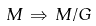Convert formula to latex. <formula><loc_0><loc_0><loc_500><loc_500>M \, \Rightarrow \, M / G</formula> 